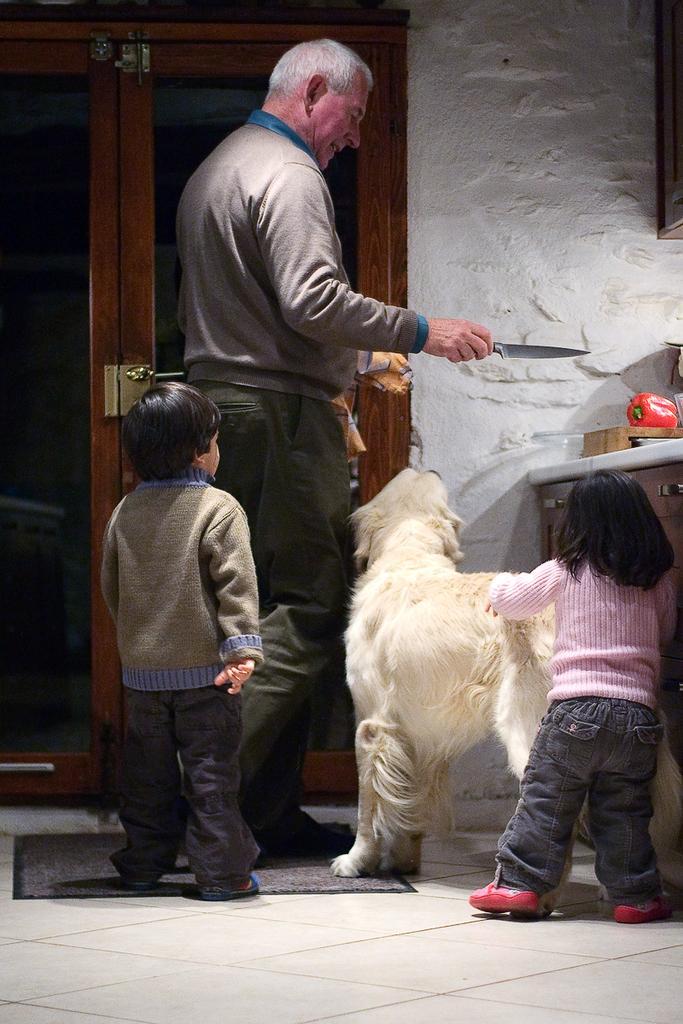Describe this image in one or two sentences. In this picture there is a man standing holding a knife, there is a dog beside him. There are two little kids standing, in the backdrop there is a door and a wall. 